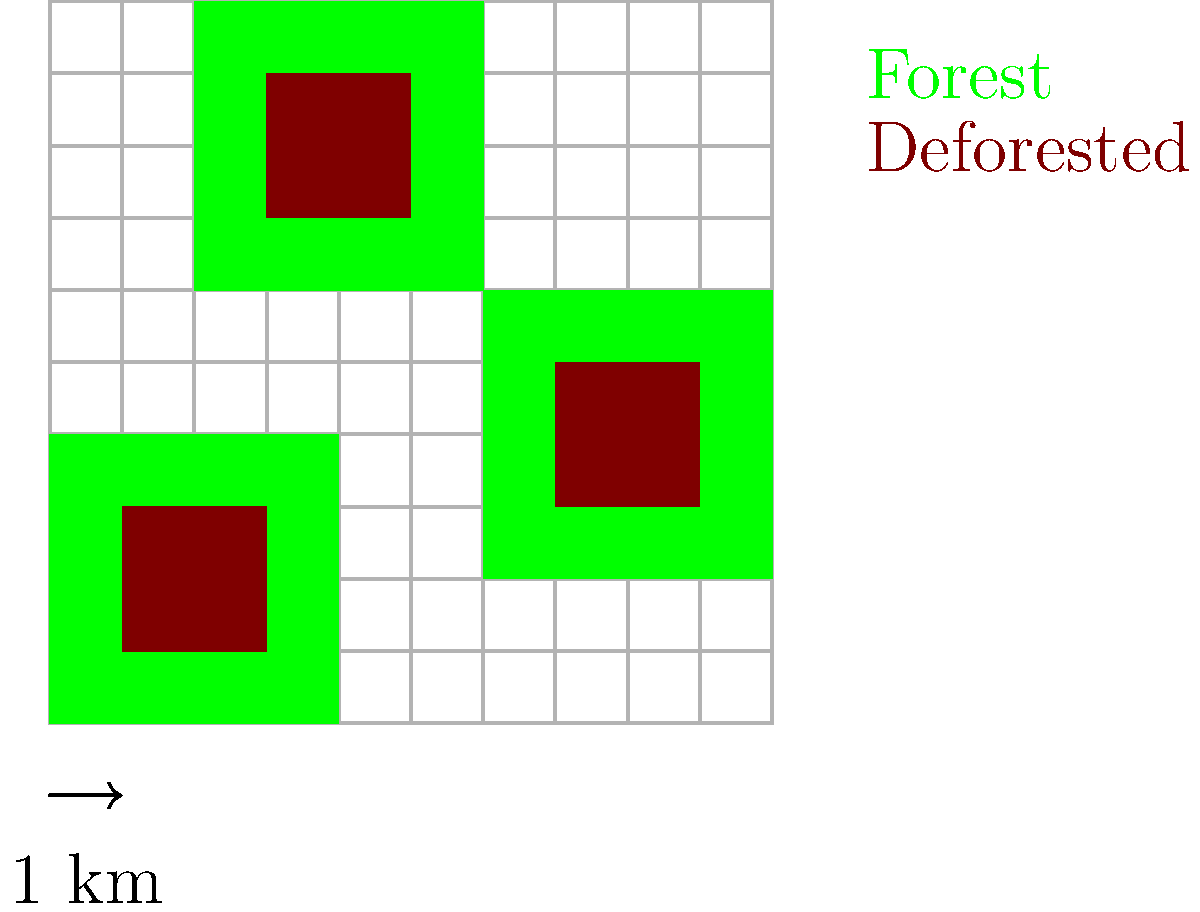As a grant writer specializing in environmental research, you're analyzing satellite imagery to track deforestation patterns. The image shows a 10km x 10km area where green represents forest cover and brown indicates deforested areas. Each grid square is 1km x 1km. What percentage of the original forest area has been deforested? To solve this problem, we need to follow these steps:

1. Calculate the total original forest area:
   - There are three forest patches: 4x4, 4x4, and 4x4 km
   - Total area = $4 \times 4 + 4 \times 4 + 4 \times 4 = 48$ sq km

2. Calculate the deforested area:
   - There are three deforested patches: 2x2, 2x2, and 2x2 km
   - Total deforested area = $2 \times 2 + 2 \times 2 + 2 \times 2 = 12$ sq km

3. Calculate the percentage of deforestation:
   - Percentage = (Deforested area / Original forest area) x 100
   - Percentage = $(12 / 48) \times 100 = 0.25 \times 100 = 25\%$

Therefore, 25% of the original forest area has been deforested.
Answer: 25% 